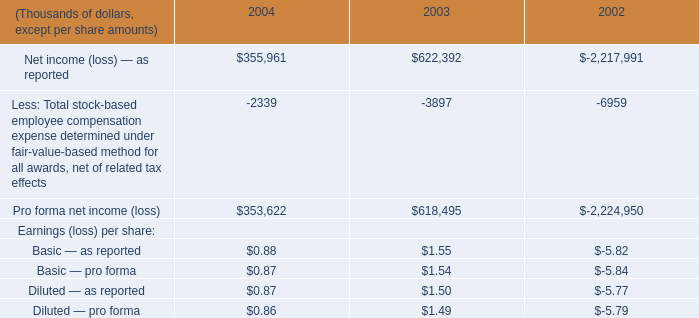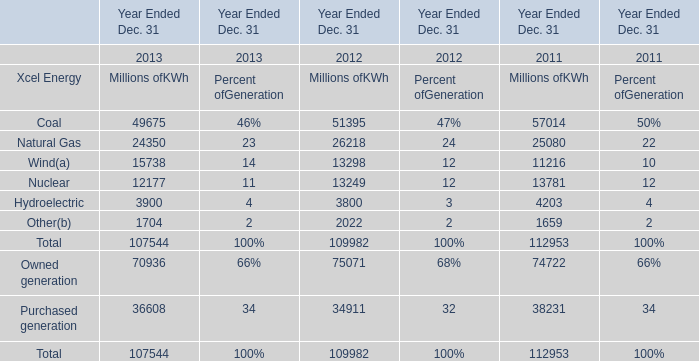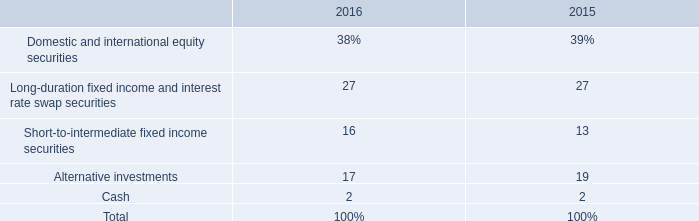How many Xcel Energy exceed the average of Xcel Energy in 2012? 
Computations: ((((((51395 + 26218) + 13298) + 13249) + 3800) + 2022) / 6)
Answer: 18330.33333. 